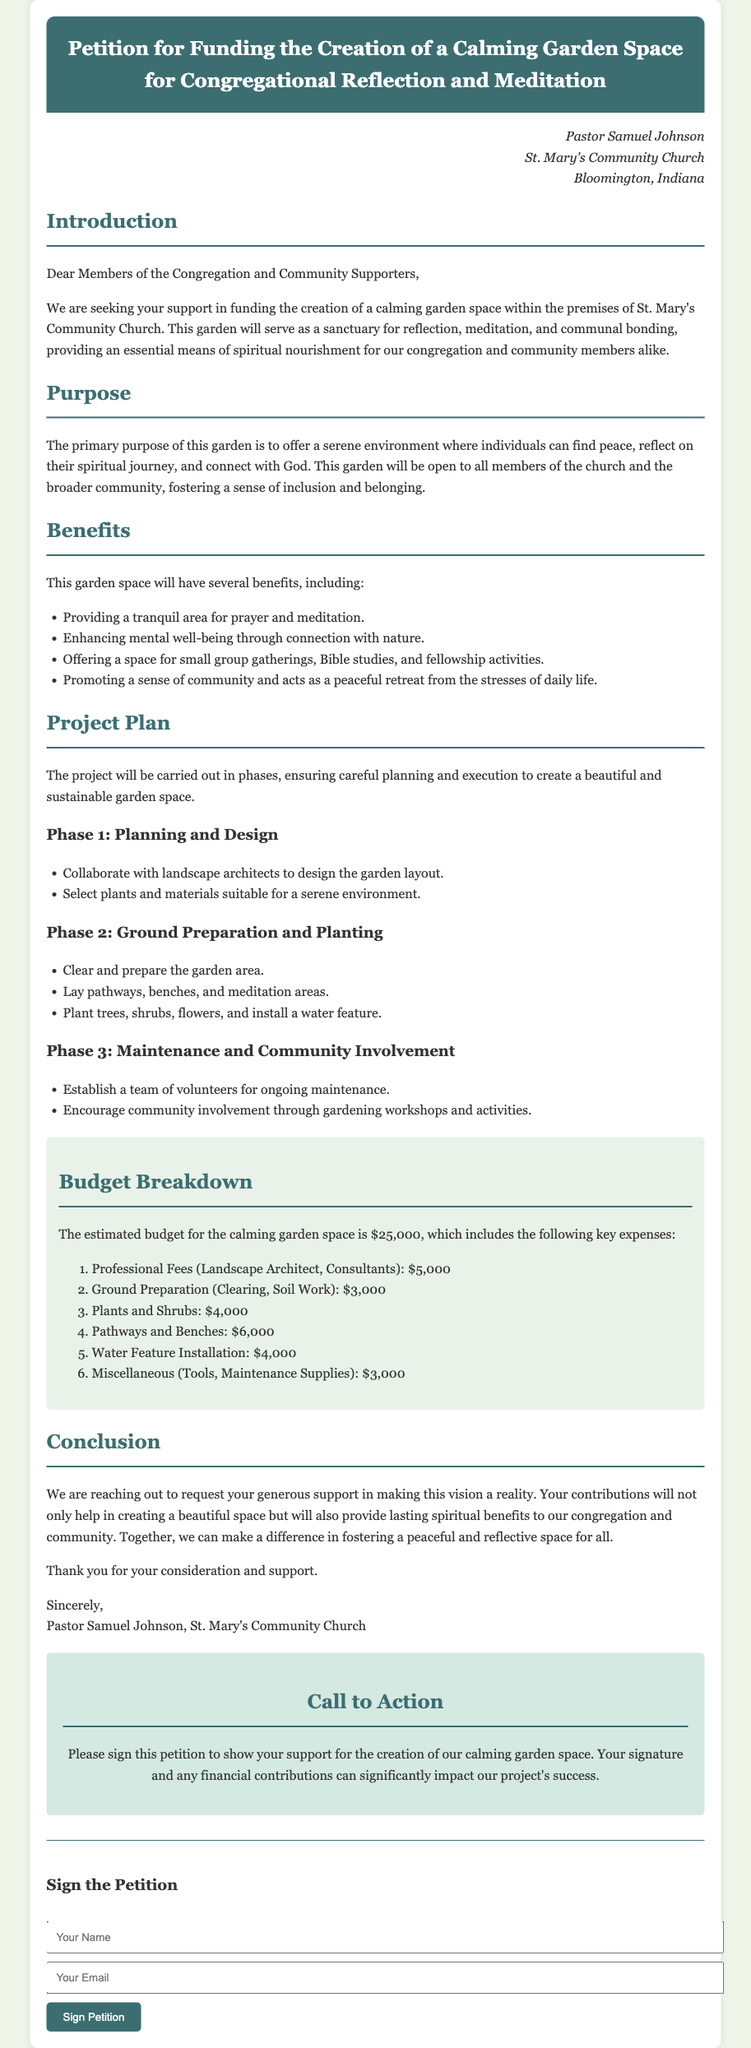What is the total budget for the garden project? The total budget is mentioned in the budget breakdown section of the document, amounting to $25,000.
Answer: $25,000 Who is the petitioner? The petitioner is identified at the beginning of the document as Pastor Samuel Johnson.
Answer: Pastor Samuel Johnson What is the primary purpose of the garden? The document outlines that the primary purpose is to offer a serene environment for individuals to find peace and connect with God.
Answer: To offer a serene environment for reflection and connection with God What is included in Phase 1 of the project plan? Phase 1 involves collaborating with landscape architects and selecting suitable plants and materials.
Answer: Collaborate with landscape architects; select plants and materials How much is allocated for professional fees in the budget? The budget breakdown specifies that professional fees for landscape architects and consultants amount to $5,000.
Answer: $5,000 What type of gathering is encouraged in the garden space? The benefits section mentions that small group gatherings, Bible studies, and fellowship activities will take place in the garden.
Answer: Small group gatherings, Bible studies, fellowship activities What color is the background of the document? The background color specified in the style section is a light shade (#f0f5e9).
Answer: Light shade (#f0f5e9) What is the concluding request made by the petitioner? The conclusion reiterates the request for generous support to help make the garden vision a reality.
Answer: Request for generous support How will the community be involved in the garden maintenance? The document states that a team of volunteers will be established for ongoing maintenance, encouraging community involvement through gardening workshops.
Answer: Establish a team of volunteers for maintenance; gardening workshops 